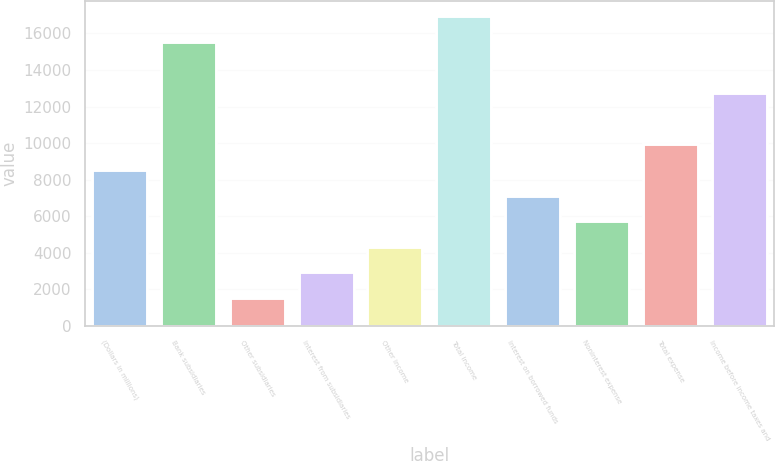Convert chart. <chart><loc_0><loc_0><loc_500><loc_500><bar_chart><fcel>(Dollars in millions)<fcel>Bank subsidiaries<fcel>Other subsidiaries<fcel>Interest from subsidiaries<fcel>Other income<fcel>Total income<fcel>Interest on borrowed funds<fcel>Noninterest expense<fcel>Total expense<fcel>Income before income taxes and<nl><fcel>8534.6<fcel>15545.1<fcel>1524.1<fcel>2926.2<fcel>4328.3<fcel>16947.2<fcel>7132.5<fcel>5730.4<fcel>9936.7<fcel>12740.9<nl></chart> 